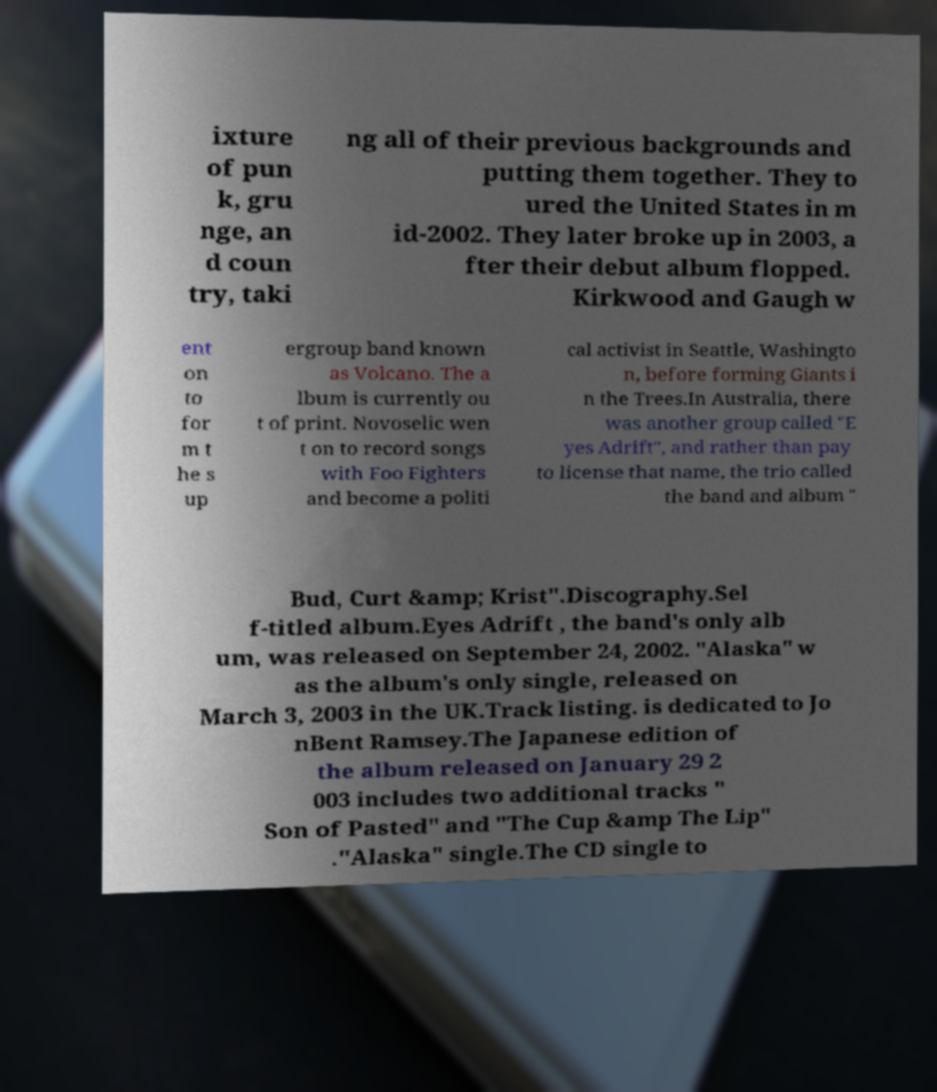Can you accurately transcribe the text from the provided image for me? ixture of pun k, gru nge, an d coun try, taki ng all of their previous backgrounds and putting them together. They to ured the United States in m id-2002. They later broke up in 2003, a fter their debut album flopped. Kirkwood and Gaugh w ent on to for m t he s up ergroup band known as Volcano. The a lbum is currently ou t of print. Novoselic wen t on to record songs with Foo Fighters and become a politi cal activist in Seattle, Washingto n, before forming Giants i n the Trees.In Australia, there was another group called "E yes Adrift", and rather than pay to license that name, the trio called the band and album " Bud, Curt &amp; Krist".Discography.Sel f-titled album.Eyes Adrift , the band's only alb um, was released on September 24, 2002. "Alaska" w as the album's only single, released on March 3, 2003 in the UK.Track listing. is dedicated to Jo nBent Ramsey.The Japanese edition of the album released on January 29 2 003 includes two additional tracks " Son of Pasted" and "The Cup &amp The Lip" ."Alaska" single.The CD single to 